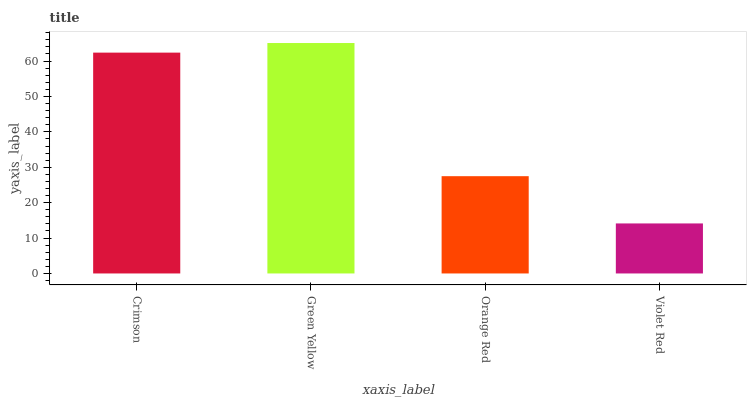Is Violet Red the minimum?
Answer yes or no. Yes. Is Green Yellow the maximum?
Answer yes or no. Yes. Is Orange Red the minimum?
Answer yes or no. No. Is Orange Red the maximum?
Answer yes or no. No. Is Green Yellow greater than Orange Red?
Answer yes or no. Yes. Is Orange Red less than Green Yellow?
Answer yes or no. Yes. Is Orange Red greater than Green Yellow?
Answer yes or no. No. Is Green Yellow less than Orange Red?
Answer yes or no. No. Is Crimson the high median?
Answer yes or no. Yes. Is Orange Red the low median?
Answer yes or no. Yes. Is Violet Red the high median?
Answer yes or no. No. Is Violet Red the low median?
Answer yes or no. No. 